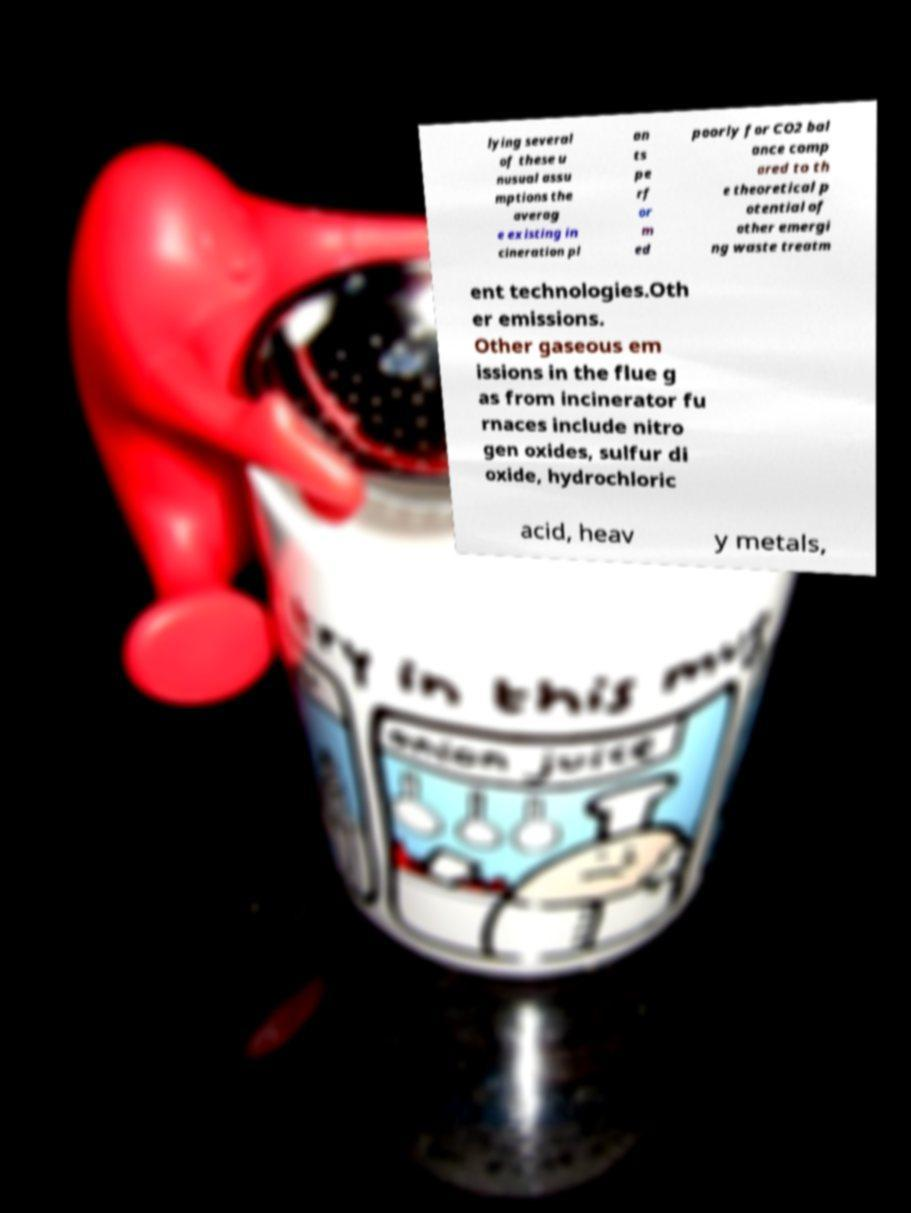I need the written content from this picture converted into text. Can you do that? lying several of these u nusual assu mptions the averag e existing in cineration pl an ts pe rf or m ed poorly for CO2 bal ance comp ared to th e theoretical p otential of other emergi ng waste treatm ent technologies.Oth er emissions. Other gaseous em issions in the flue g as from incinerator fu rnaces include nitro gen oxides, sulfur di oxide, hydrochloric acid, heav y metals, 